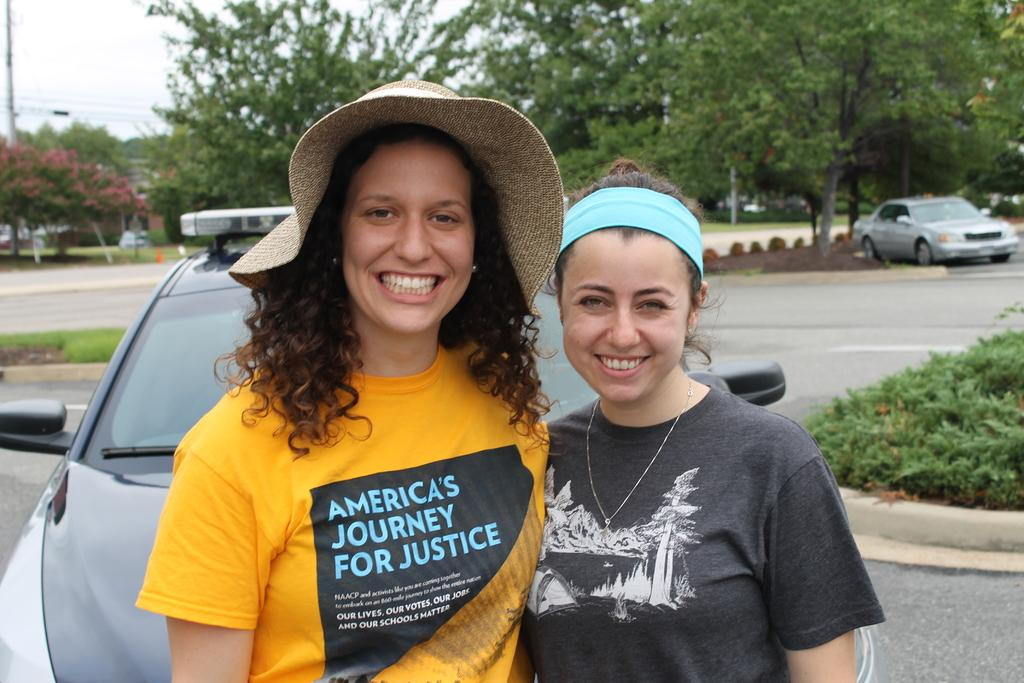What can be seen in the image? There are women standing in the image. How are the women in the image? The women are smiling. What can be seen in the background of the image? There are trees, the sky, electric poles, electric cables, a road, motor vehicles, and plants visible in the background. What is the ground like in the image? The ground is visible in the image. Can you describe the setting of the image? The image appears to be taken outdoors, with a road, trees, and plants in the background. What type of lace can be seen on the chairs in the image? There are no chairs present in the image, so there is no lace to be seen. What news is being reported by the women in the image? There is no indication in the image that the women are reporting any news. 